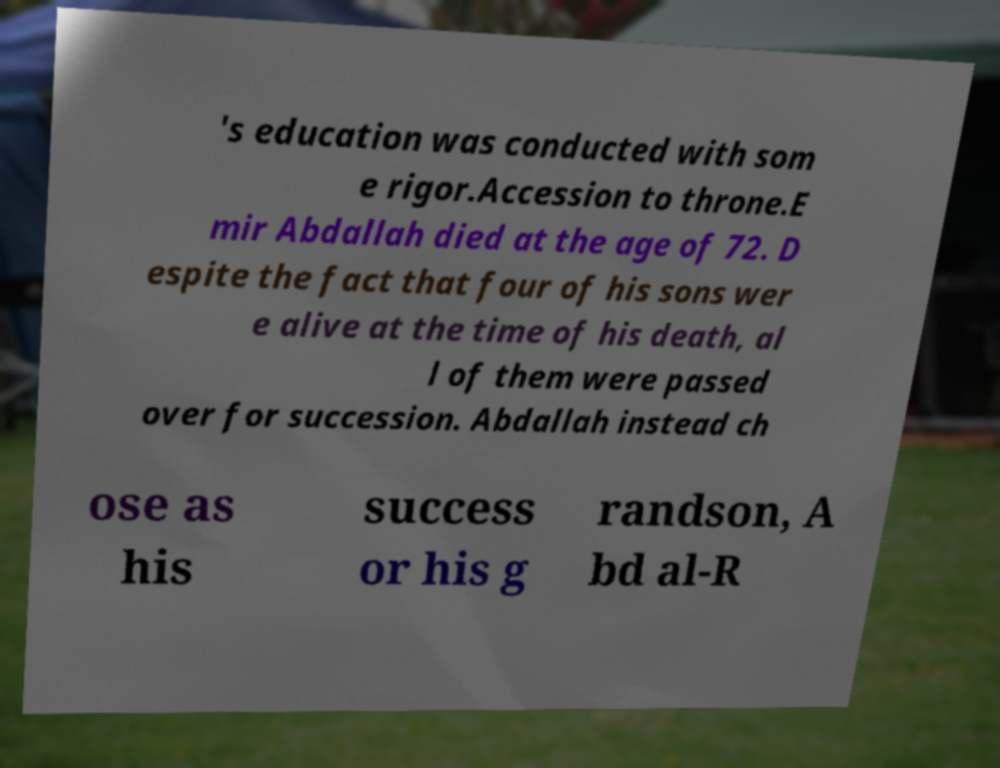Could you assist in decoding the text presented in this image and type it out clearly? 's education was conducted with som e rigor.Accession to throne.E mir Abdallah died at the age of 72. D espite the fact that four of his sons wer e alive at the time of his death, al l of them were passed over for succession. Abdallah instead ch ose as his success or his g randson, A bd al-R 